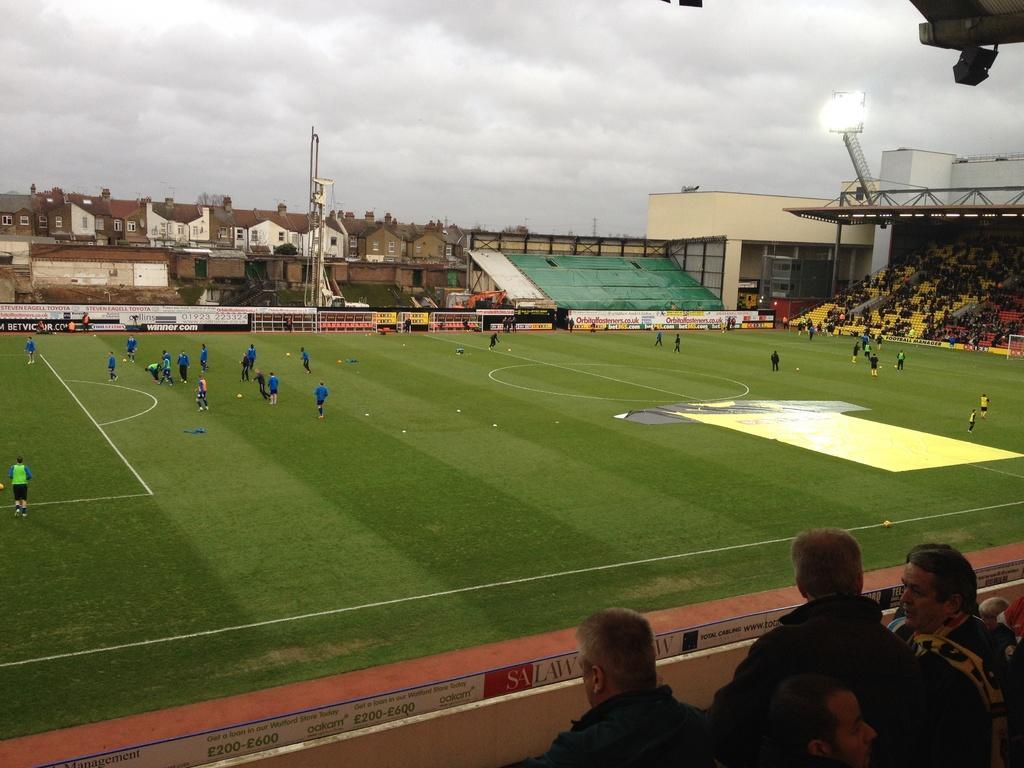In one or two sentences, can you explain what this image depicts? In the center of the image there are people playing in the playground. To the right side of the image there are people sitting in stands. In the background of the image there are houses, sky and clouds. To the right side of the image there are stadium lights. At the bottom of the image there are people. 